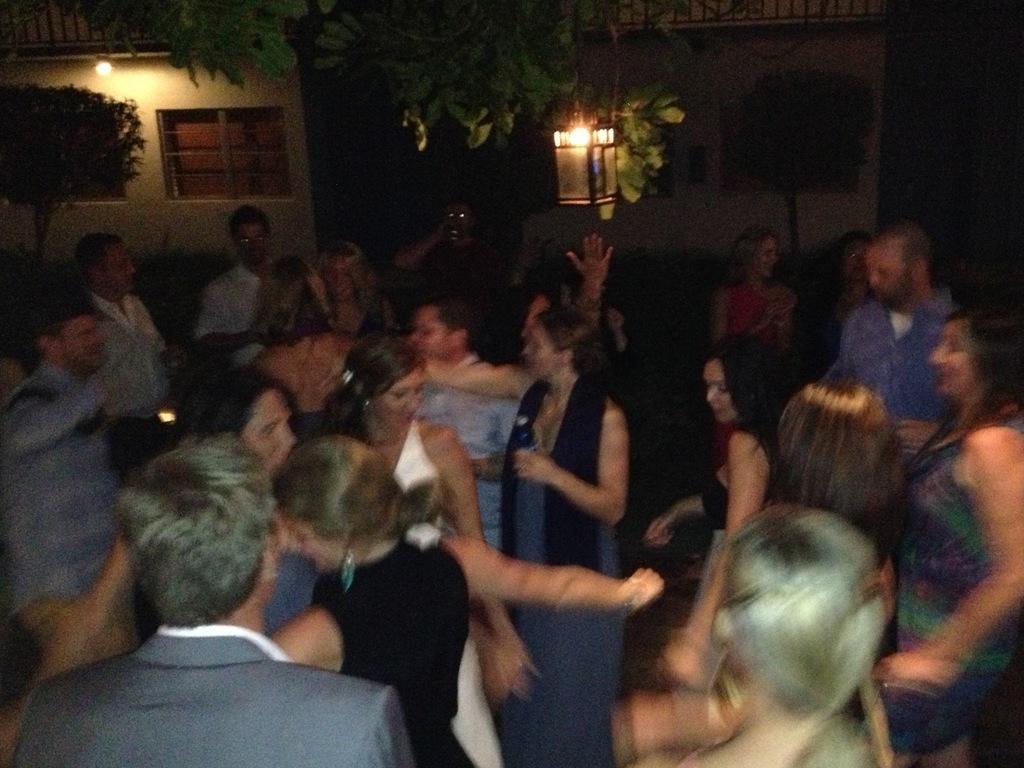How would you summarize this image in a sentence or two? In this image we can see a group of people. In the background of the image there are some houses, trees, lights and some other objects. 